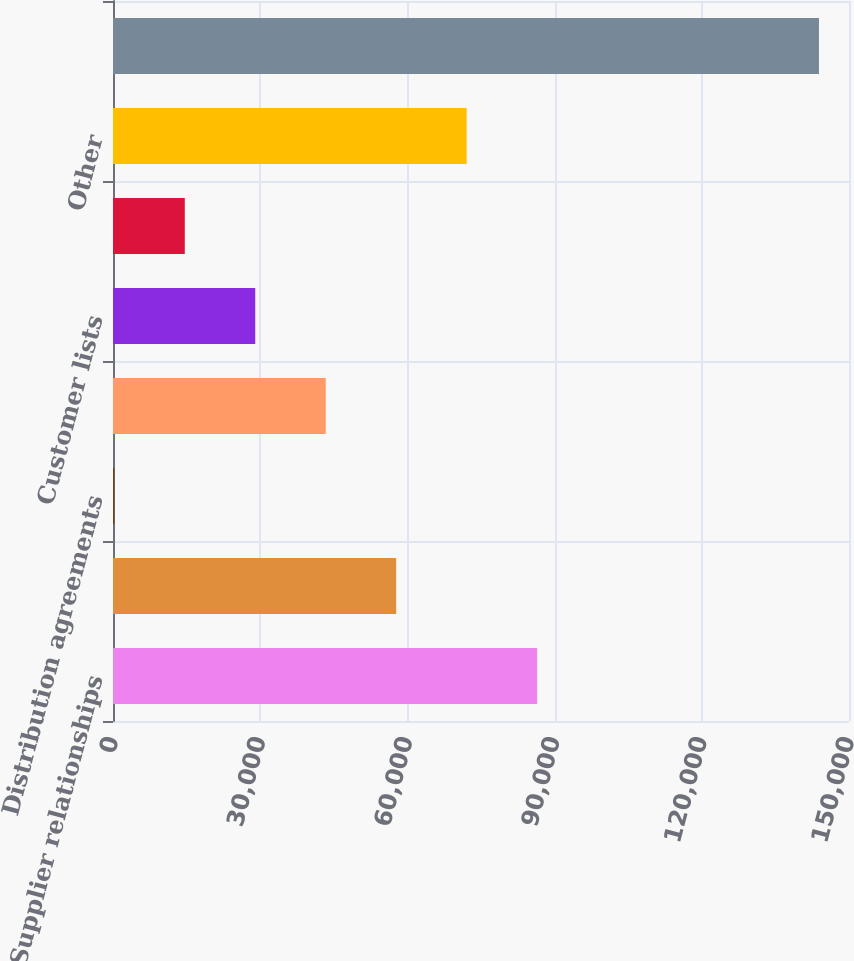Convert chart to OTSL. <chart><loc_0><loc_0><loc_500><loc_500><bar_chart><fcel>Supplier relationships<fcel>Technology<fcel>Distribution agreements<fcel>Affiliate agreements<fcel>Customer lists<fcel>Domain names<fcel>Other<fcel>Total<nl><fcel>86435.2<fcel>57713.8<fcel>271<fcel>43353.1<fcel>28992.4<fcel>14631.7<fcel>72074.5<fcel>143878<nl></chart> 